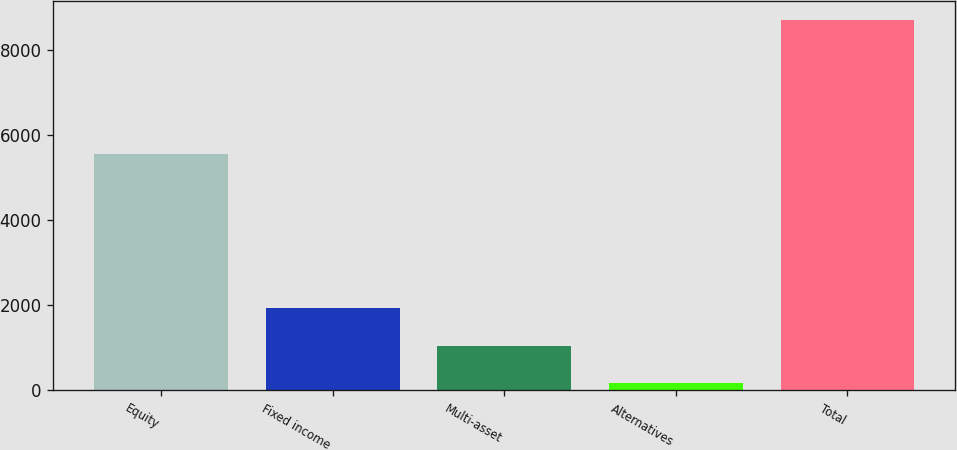<chart> <loc_0><loc_0><loc_500><loc_500><bar_chart><fcel>Equity<fcel>Fixed income<fcel>Multi-asset<fcel>Alternatives<fcel>Total<nl><fcel>5561<fcel>1934<fcel>1043<fcel>162<fcel>8700<nl></chart> 